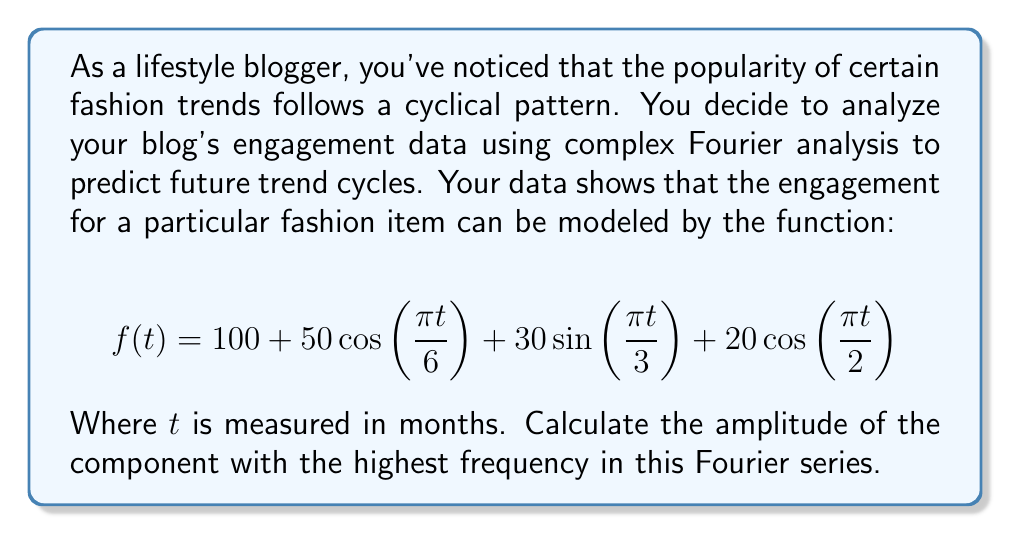Solve this math problem. To solve this problem, we need to follow these steps:

1) First, recall that a Fourier series is typically written in the form:

   $$f(t) = a_0 + \sum_{n=1}^{\infty} (a_n\cos(n\omega t) + b_n\sin(n\omega t))$$

2) In our case, we have:
   
   $$f(t) = 100 + 50\cos(\frac{\pi t}{6}) + 30\sin(\frac{\pi t}{3}) + 20\cos(\frac{\pi t}{2})$$

3) We can identify the components:
   - $a_0 = 100$ (constant term)
   - $50\cos(\frac{\pi t}{6})$ has frequency $\frac{\pi}{6}$
   - $30\sin(\frac{\pi t}{3})$ has frequency $\frac{\pi}{3}$
   - $20\cos(\frac{\pi t}{2})$ has frequency $\frac{\pi}{2}$

4) The highest frequency is $\frac{\pi}{2}$, corresponding to the term $20\cos(\frac{\pi t}{2})$

5) For a cosine term $a\cos(\omega t)$, the amplitude is simply $|a|$

Therefore, the amplitude of the highest frequency component is 20.

This analysis shows that the fastest-changing component of your trend cycle has an amplitude of 20, which could represent quick fluctuations in engagement superimposed on slower seasonal variations.
Answer: 20 